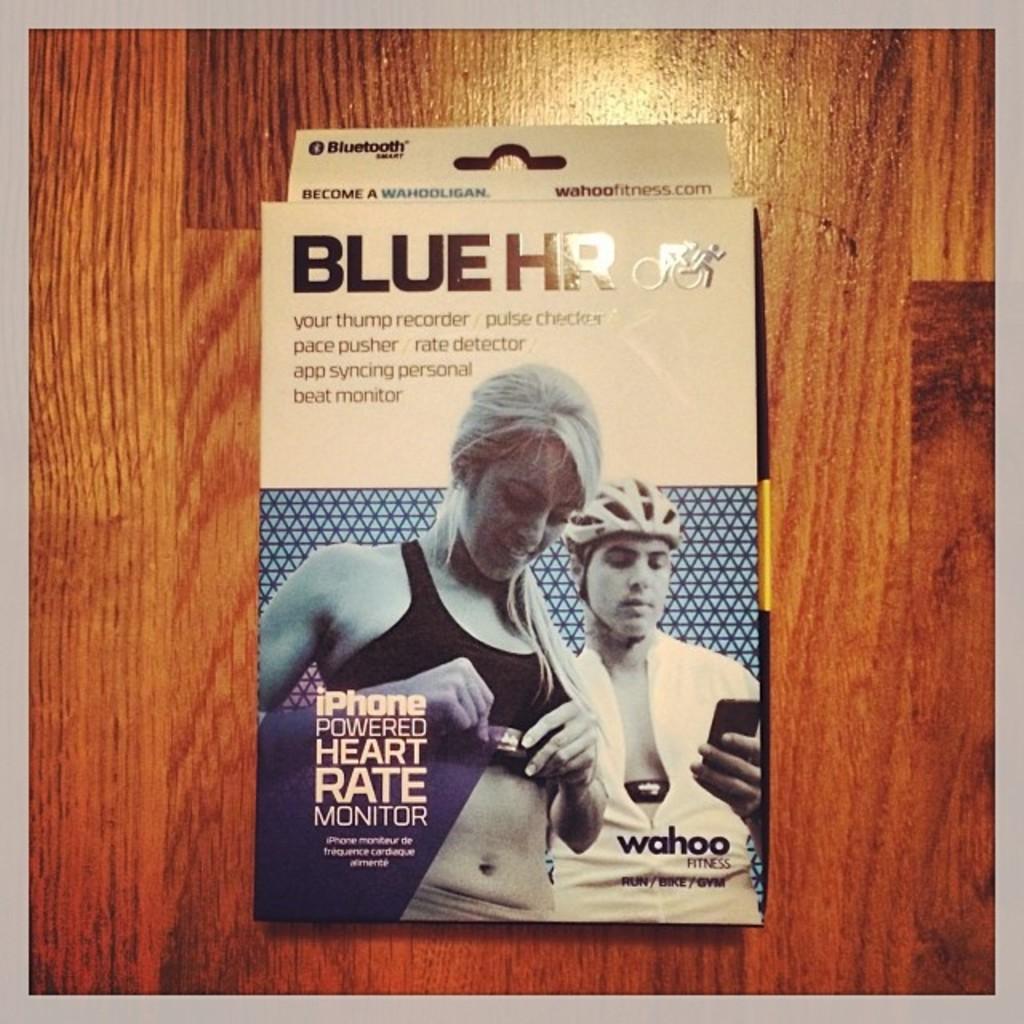What is the top left word on the package?
Offer a terse response. Bluetooth. 